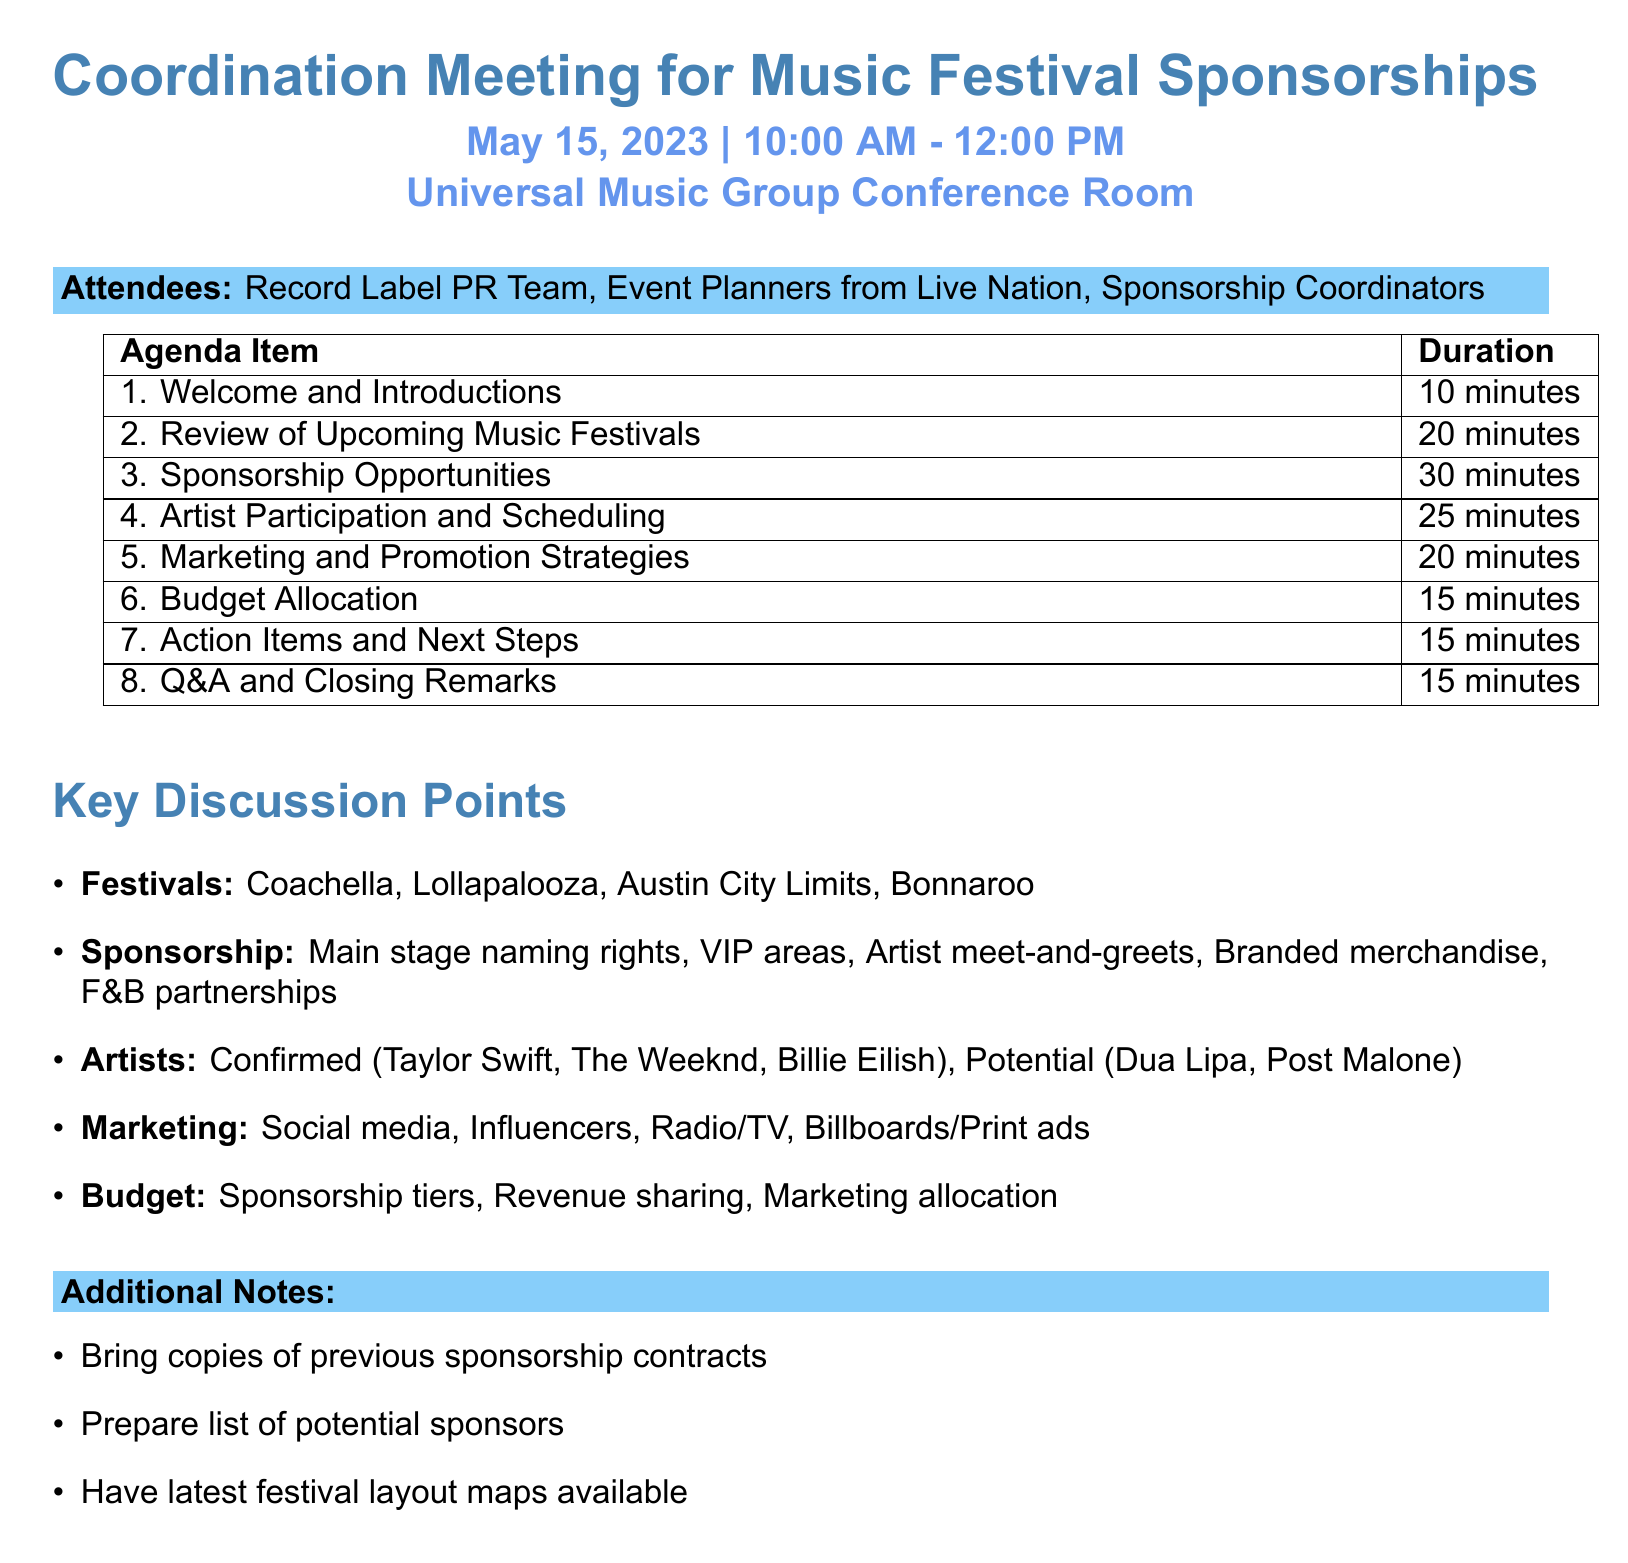What is the title of the meeting? The title of the meeting is specified in the document under "meetingTitle."
Answer: Coordination Meeting for Music Festival Sponsorships When is the meeting scheduled? The meeting date is given in the document under "date."
Answer: May 15, 2023 How long is the "Sponsorship Opportunities" agenda item? The duration is stated in the agenda section.
Answer: 30 minutes Which artists are confirmed for participation? The confirmed artists are listed in the "Artist Participation and Scheduling" section.
Answer: Taylor Swift, The Weeknd, Billie Eilish What are the two types of sponsorships mentioned? The document lists various sponsorships under the "Sponsorship Opportunities" section.
Answer: Main stage naming rights, VIP area sponsorships What is one marketing strategy discussed in the meeting? The document lists marketing strategies in the "Marketing and Promotion Strategies" section.
Answer: Social media campaigns Who are the attendees of this meeting? The attendees are listed in the document under "attendees."
Answer: Record Label PR Team, Event Planners from Live Nation, Sponsorship Coordinators What is one action item mentioned for the next steps? Action items are listed in the "Action Items and Next Steps" section of the agenda.
Answer: Assign responsibilities for follow-up tasks 